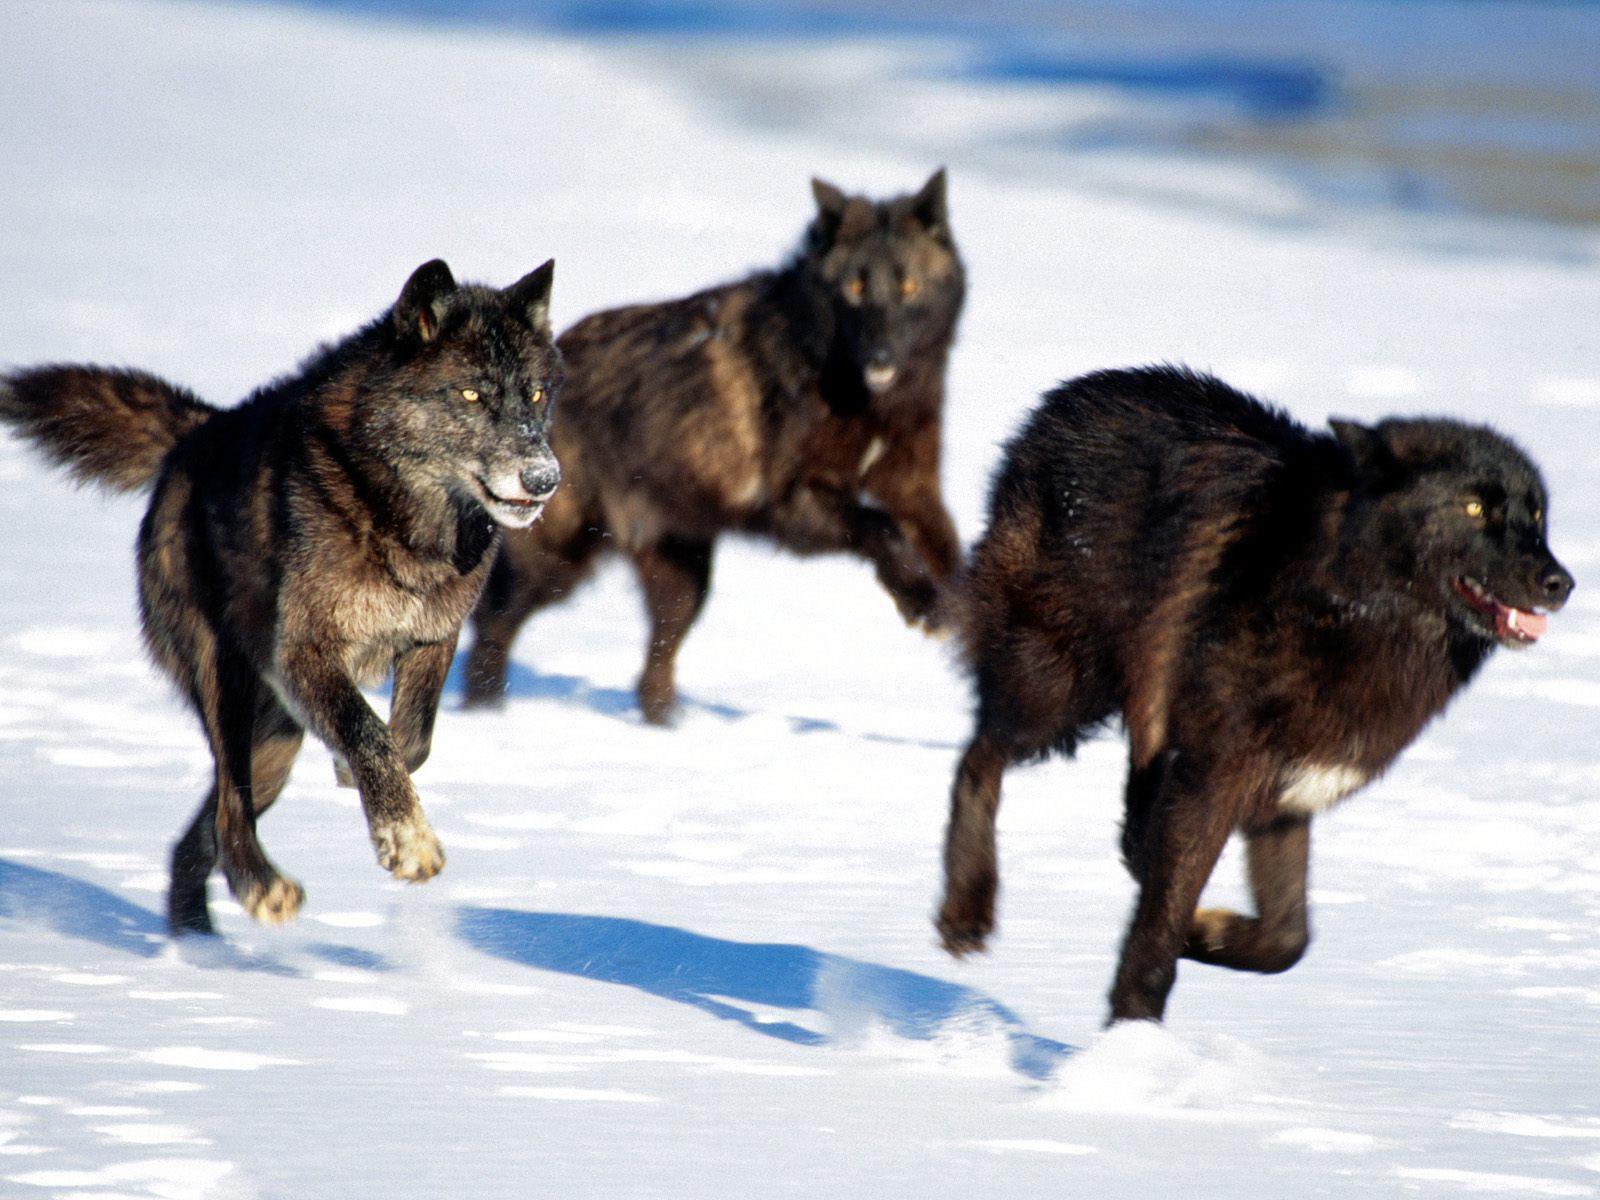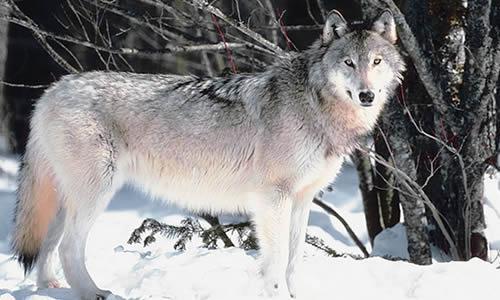The first image is the image on the left, the second image is the image on the right. Given the left and right images, does the statement "Each image shows at least three wolves in a snowy scene, and no carcass is visible in either scene." hold true? Answer yes or no. No. The first image is the image on the left, the second image is the image on the right. Assess this claim about the two images: "There are more than six wolves.". Correct or not? Answer yes or no. No. 